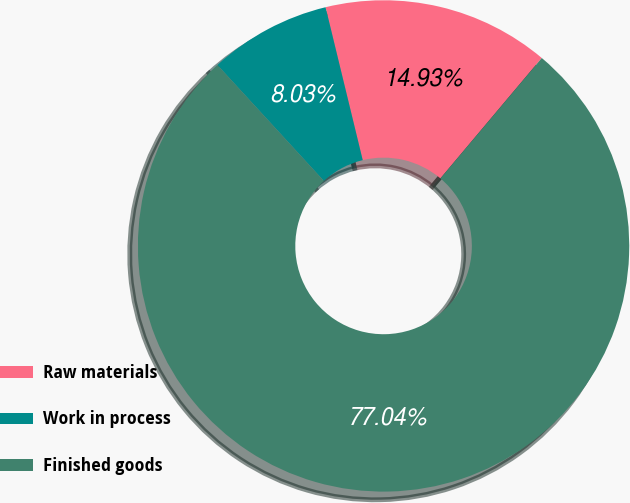Convert chart. <chart><loc_0><loc_0><loc_500><loc_500><pie_chart><fcel>Raw materials<fcel>Work in process<fcel>Finished goods<nl><fcel>14.93%<fcel>8.03%<fcel>77.04%<nl></chart> 